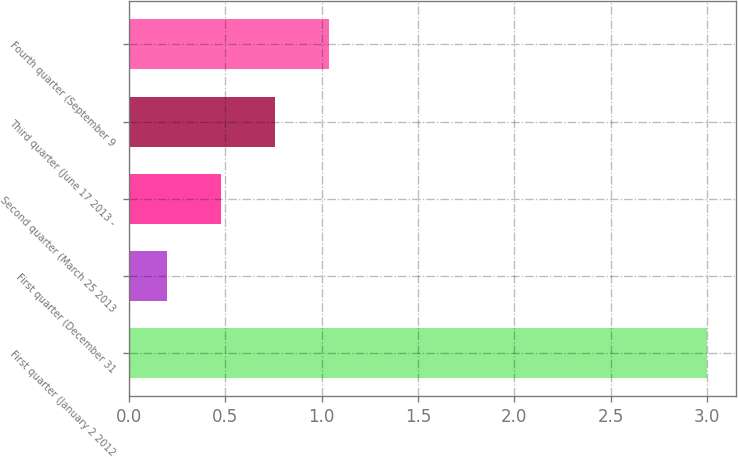Convert chart to OTSL. <chart><loc_0><loc_0><loc_500><loc_500><bar_chart><fcel>First quarter (January 2 2012<fcel>First quarter (December 31<fcel>Second quarter (March 25 2013<fcel>Third quarter (June 17 2013 -<fcel>Fourth quarter (September 9<nl><fcel>3<fcel>0.2<fcel>0.48<fcel>0.76<fcel>1.04<nl></chart> 